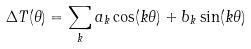Convert formula to latex. <formula><loc_0><loc_0><loc_500><loc_500>\Delta T ( \theta ) = \sum _ { k } a _ { k } \cos ( k \theta ) + b _ { k } \sin ( k \theta )</formula> 